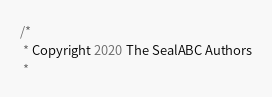<code> <loc_0><loc_0><loc_500><loc_500><_Go_>/*
 * Copyright 2020 The SealABC Authors
 *</code> 